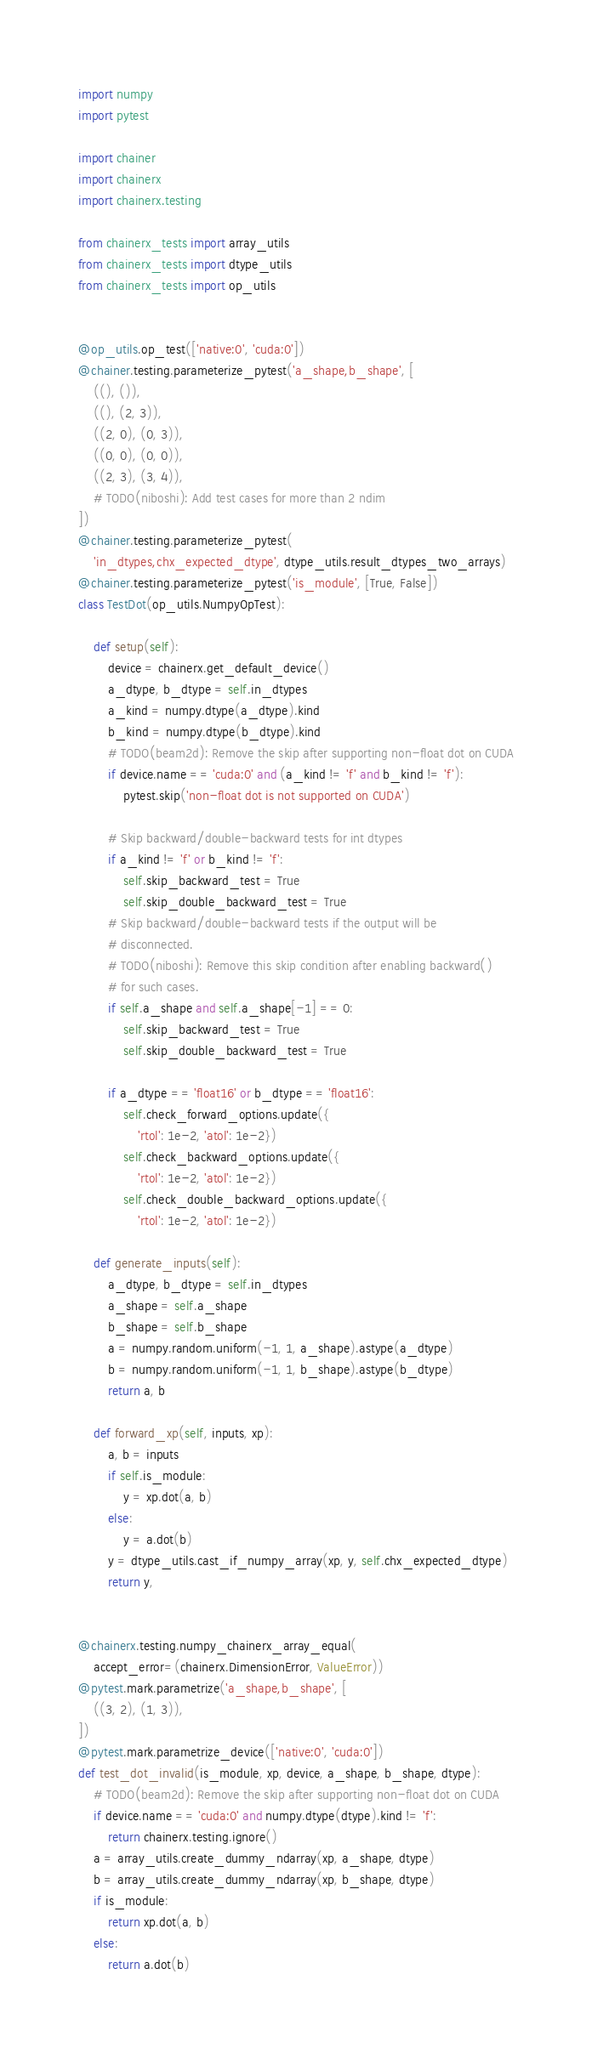Convert code to text. <code><loc_0><loc_0><loc_500><loc_500><_Python_>import numpy
import pytest

import chainer
import chainerx
import chainerx.testing

from chainerx_tests import array_utils
from chainerx_tests import dtype_utils
from chainerx_tests import op_utils


@op_utils.op_test(['native:0', 'cuda:0'])
@chainer.testing.parameterize_pytest('a_shape,b_shape', [
    ((), ()),
    ((), (2, 3)),
    ((2, 0), (0, 3)),
    ((0, 0), (0, 0)),
    ((2, 3), (3, 4)),
    # TODO(niboshi): Add test cases for more than 2 ndim
])
@chainer.testing.parameterize_pytest(
    'in_dtypes,chx_expected_dtype', dtype_utils.result_dtypes_two_arrays)
@chainer.testing.parameterize_pytest('is_module', [True, False])
class TestDot(op_utils.NumpyOpTest):

    def setup(self):
        device = chainerx.get_default_device()
        a_dtype, b_dtype = self.in_dtypes
        a_kind = numpy.dtype(a_dtype).kind
        b_kind = numpy.dtype(b_dtype).kind
        # TODO(beam2d): Remove the skip after supporting non-float dot on CUDA
        if device.name == 'cuda:0' and (a_kind != 'f' and b_kind != 'f'):
            pytest.skip('non-float dot is not supported on CUDA')

        # Skip backward/double-backward tests for int dtypes
        if a_kind != 'f' or b_kind != 'f':
            self.skip_backward_test = True
            self.skip_double_backward_test = True
        # Skip backward/double-backward tests if the output will be
        # disconnected.
        # TODO(niboshi): Remove this skip condition after enabling backward()
        # for such cases.
        if self.a_shape and self.a_shape[-1] == 0:
            self.skip_backward_test = True
            self.skip_double_backward_test = True

        if a_dtype == 'float16' or b_dtype == 'float16':
            self.check_forward_options.update({
                'rtol': 1e-2, 'atol': 1e-2})
            self.check_backward_options.update({
                'rtol': 1e-2, 'atol': 1e-2})
            self.check_double_backward_options.update({
                'rtol': 1e-2, 'atol': 1e-2})

    def generate_inputs(self):
        a_dtype, b_dtype = self.in_dtypes
        a_shape = self.a_shape
        b_shape = self.b_shape
        a = numpy.random.uniform(-1, 1, a_shape).astype(a_dtype)
        b = numpy.random.uniform(-1, 1, b_shape).astype(b_dtype)
        return a, b

    def forward_xp(self, inputs, xp):
        a, b = inputs
        if self.is_module:
            y = xp.dot(a, b)
        else:
            y = a.dot(b)
        y = dtype_utils.cast_if_numpy_array(xp, y, self.chx_expected_dtype)
        return y,


@chainerx.testing.numpy_chainerx_array_equal(
    accept_error=(chainerx.DimensionError, ValueError))
@pytest.mark.parametrize('a_shape,b_shape', [
    ((3, 2), (1, 3)),
])
@pytest.mark.parametrize_device(['native:0', 'cuda:0'])
def test_dot_invalid(is_module, xp, device, a_shape, b_shape, dtype):
    # TODO(beam2d): Remove the skip after supporting non-float dot on CUDA
    if device.name == 'cuda:0' and numpy.dtype(dtype).kind != 'f':
        return chainerx.testing.ignore()
    a = array_utils.create_dummy_ndarray(xp, a_shape, dtype)
    b = array_utils.create_dummy_ndarray(xp, b_shape, dtype)
    if is_module:
        return xp.dot(a, b)
    else:
        return a.dot(b)
</code> 